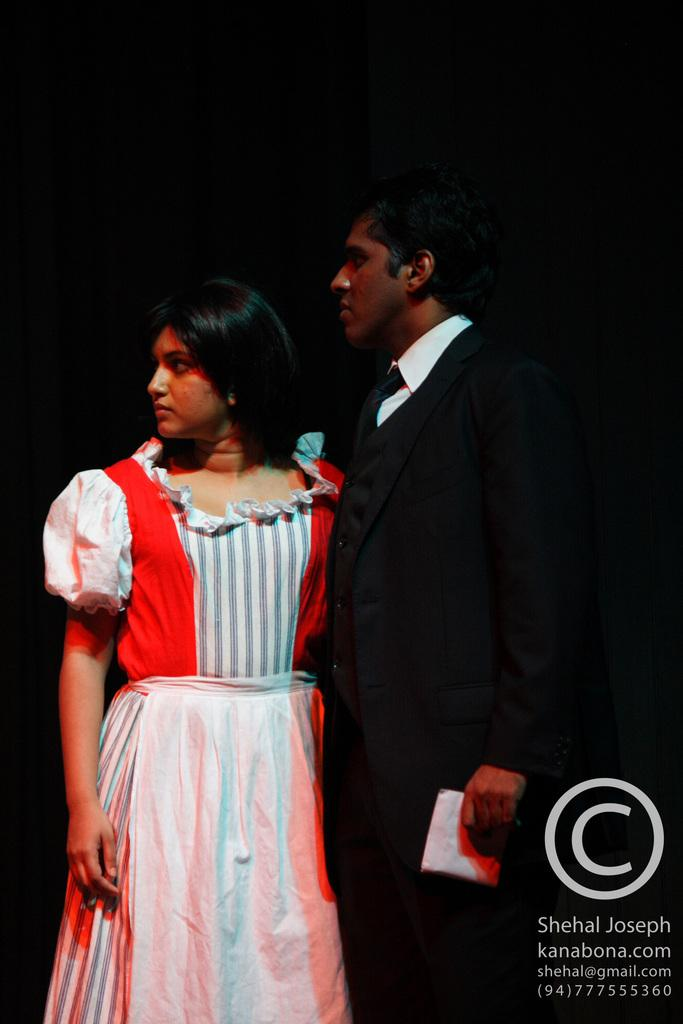Who is present in the image? There is a couple in the image. What is one person holding in their hand? One person is holding a cloth in their hand. What can be observed about the lighting in the image? The background of the image is dark. What type of bridge can be seen in the background of the image? There is no bridge present in the image; the background is dark. 